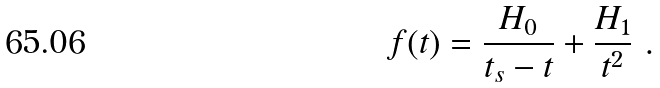<formula> <loc_0><loc_0><loc_500><loc_500>f ( t ) = \frac { H _ { 0 } } { t _ { s } - t } + \frac { H _ { 1 } } { t ^ { 2 } } \ .</formula> 